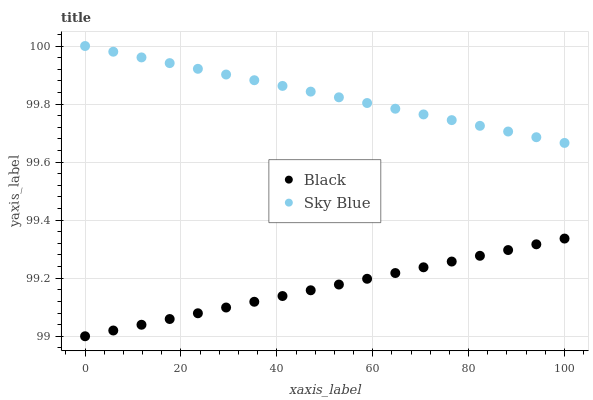Does Black have the minimum area under the curve?
Answer yes or no. Yes. Does Sky Blue have the maximum area under the curve?
Answer yes or no. Yes. Does Black have the maximum area under the curve?
Answer yes or no. No. Is Black the smoothest?
Answer yes or no. Yes. Is Sky Blue the roughest?
Answer yes or no. Yes. Is Black the roughest?
Answer yes or no. No. Does Black have the lowest value?
Answer yes or no. Yes. Does Sky Blue have the highest value?
Answer yes or no. Yes. Does Black have the highest value?
Answer yes or no. No. Is Black less than Sky Blue?
Answer yes or no. Yes. Is Sky Blue greater than Black?
Answer yes or no. Yes. Does Black intersect Sky Blue?
Answer yes or no. No. 